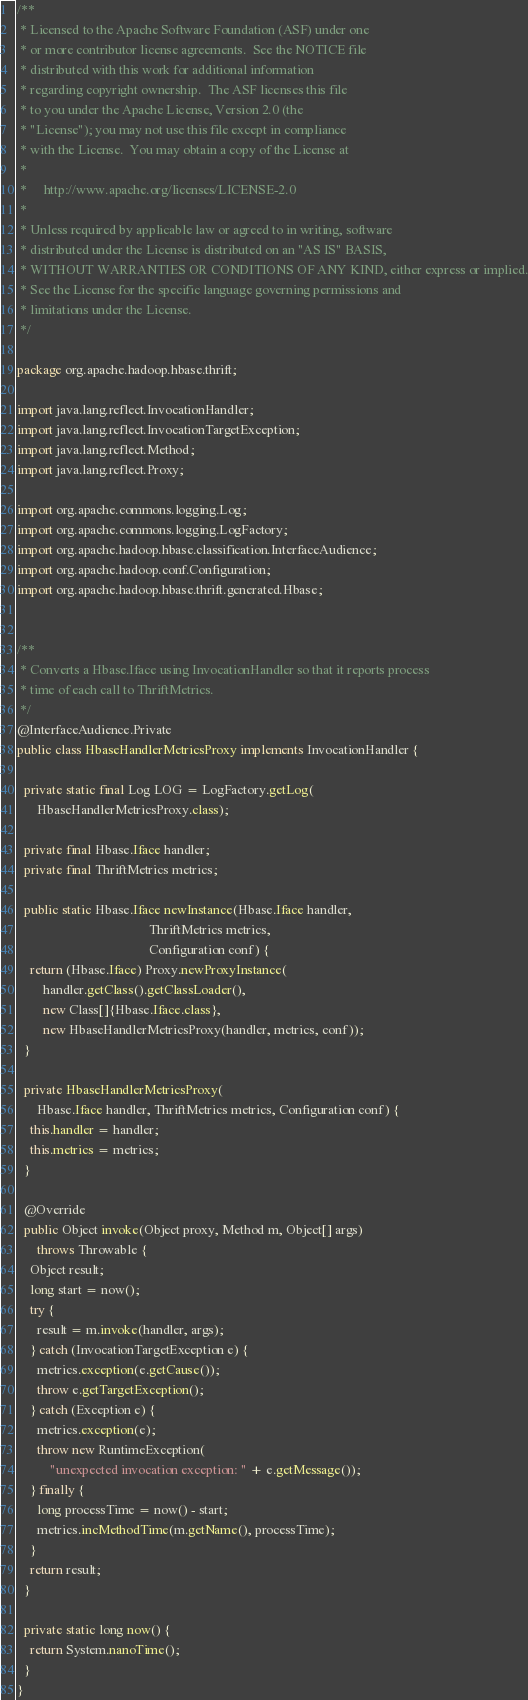<code> <loc_0><loc_0><loc_500><loc_500><_Java_>/**
 * Licensed to the Apache Software Foundation (ASF) under one
 * or more contributor license agreements.  See the NOTICE file
 * distributed with this work for additional information
 * regarding copyright ownership.  The ASF licenses this file
 * to you under the Apache License, Version 2.0 (the
 * "License"); you may not use this file except in compliance
 * with the License.  You may obtain a copy of the License at
 *
 *     http://www.apache.org/licenses/LICENSE-2.0
 *
 * Unless required by applicable law or agreed to in writing, software
 * distributed under the License is distributed on an "AS IS" BASIS,
 * WITHOUT WARRANTIES OR CONDITIONS OF ANY KIND, either express or implied.
 * See the License for the specific language governing permissions and
 * limitations under the License.
 */

package org.apache.hadoop.hbase.thrift;

import java.lang.reflect.InvocationHandler;
import java.lang.reflect.InvocationTargetException;
import java.lang.reflect.Method;
import java.lang.reflect.Proxy;

import org.apache.commons.logging.Log;
import org.apache.commons.logging.LogFactory;
import org.apache.hadoop.hbase.classification.InterfaceAudience;
import org.apache.hadoop.conf.Configuration;
import org.apache.hadoop.hbase.thrift.generated.Hbase;


/**
 * Converts a Hbase.Iface using InvocationHandler so that it reports process
 * time of each call to ThriftMetrics.
 */
@InterfaceAudience.Private
public class HbaseHandlerMetricsProxy implements InvocationHandler {

  private static final Log LOG = LogFactory.getLog(
      HbaseHandlerMetricsProxy.class);

  private final Hbase.Iface handler;
  private final ThriftMetrics metrics;

  public static Hbase.Iface newInstance(Hbase.Iface handler,
                                        ThriftMetrics metrics,
                                        Configuration conf) {
    return (Hbase.Iface) Proxy.newProxyInstance(
        handler.getClass().getClassLoader(),
        new Class[]{Hbase.Iface.class},
        new HbaseHandlerMetricsProxy(handler, metrics, conf));
  }

  private HbaseHandlerMetricsProxy(
      Hbase.Iface handler, ThriftMetrics metrics, Configuration conf) {
    this.handler = handler;
    this.metrics = metrics;
  }

  @Override
  public Object invoke(Object proxy, Method m, Object[] args)
      throws Throwable {
    Object result;
    long start = now();
    try {
      result = m.invoke(handler, args);
    } catch (InvocationTargetException e) {
      metrics.exception(e.getCause());
      throw e.getTargetException();
    } catch (Exception e) {
      metrics.exception(e);
      throw new RuntimeException(
          "unexpected invocation exception: " + e.getMessage());
    } finally {
      long processTime = now() - start;
      metrics.incMethodTime(m.getName(), processTime);
    }
    return result;
  }
  
  private static long now() {
    return System.nanoTime();
  }
}
</code> 